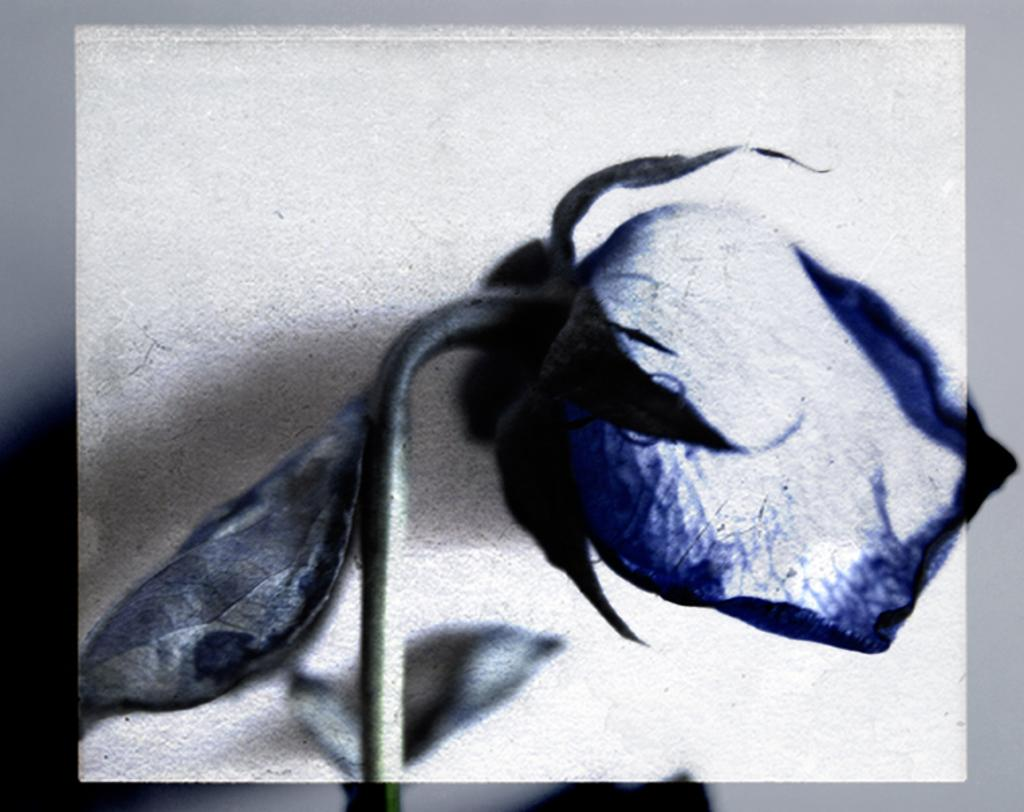What is the main subject of the image? There is a rose flower in the center of the image. Are there any other elements related to the rose flower? Yes, there are leaves associated with the rose flower. What is the color of the border surrounding the image? The image has an ash color border. What time of day is depicted in the image? The image does not depict a specific time of day, as it only features a rose flower, leaves, and an ash color border. Can you describe the cloud formation in the image? There are no clouds present in the image; it only features a rose flower, leaves, and an ash color border. 